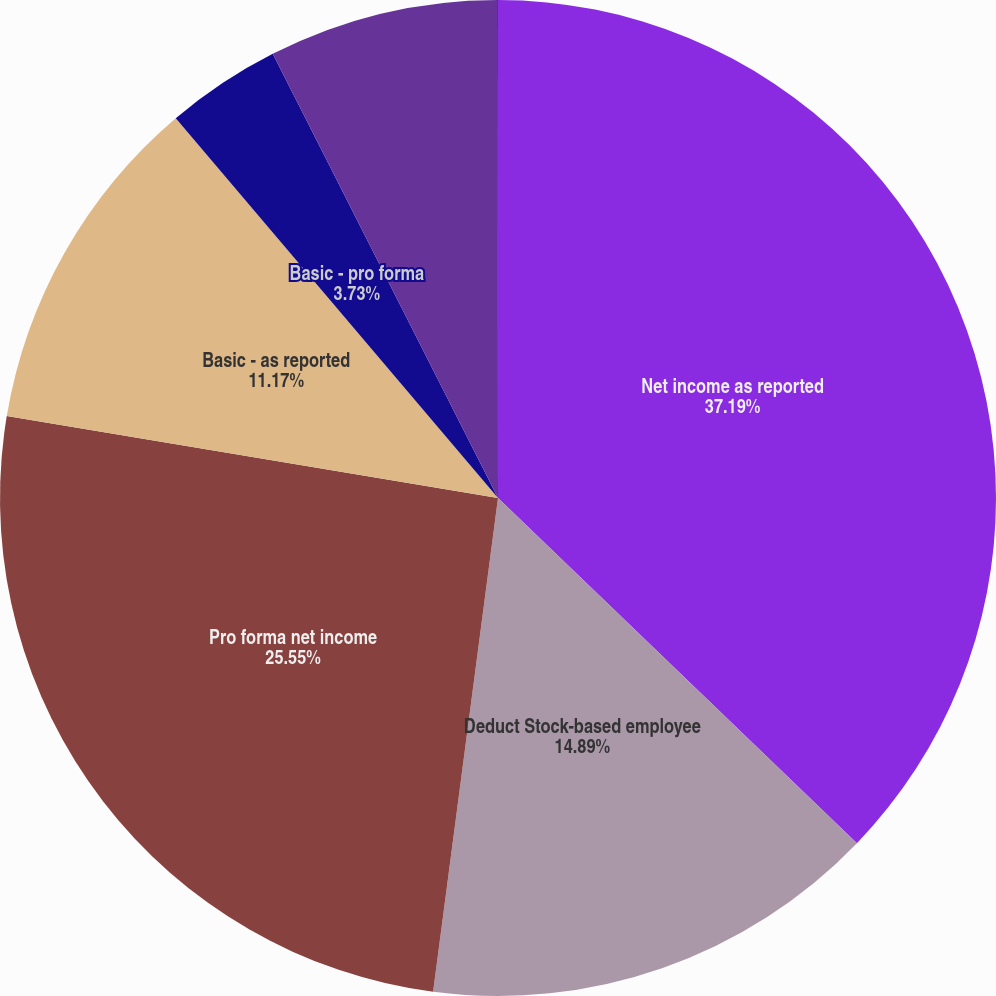Convert chart to OTSL. <chart><loc_0><loc_0><loc_500><loc_500><pie_chart><fcel>Net income as reported<fcel>Deduct Stock-based employee<fcel>Pro forma net income<fcel>Basic - as reported<fcel>Basic - pro forma<fcel>Diluted - as reported<fcel>Diluted - pro forma<nl><fcel>37.19%<fcel>14.89%<fcel>25.55%<fcel>11.17%<fcel>3.73%<fcel>7.45%<fcel>0.02%<nl></chart> 